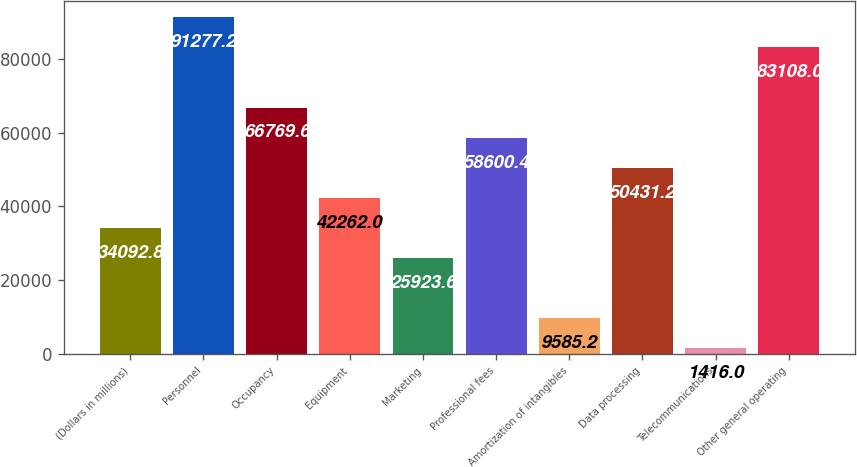Convert chart. <chart><loc_0><loc_0><loc_500><loc_500><bar_chart><fcel>(Dollars in millions)<fcel>Personnel<fcel>Occupancy<fcel>Equipment<fcel>Marketing<fcel>Professional fees<fcel>Amortization of intangibles<fcel>Data processing<fcel>Telecommunications<fcel>Other general operating<nl><fcel>34092.8<fcel>91277.2<fcel>66769.6<fcel>42262<fcel>25923.6<fcel>58600.4<fcel>9585.2<fcel>50431.2<fcel>1416<fcel>83108<nl></chart> 